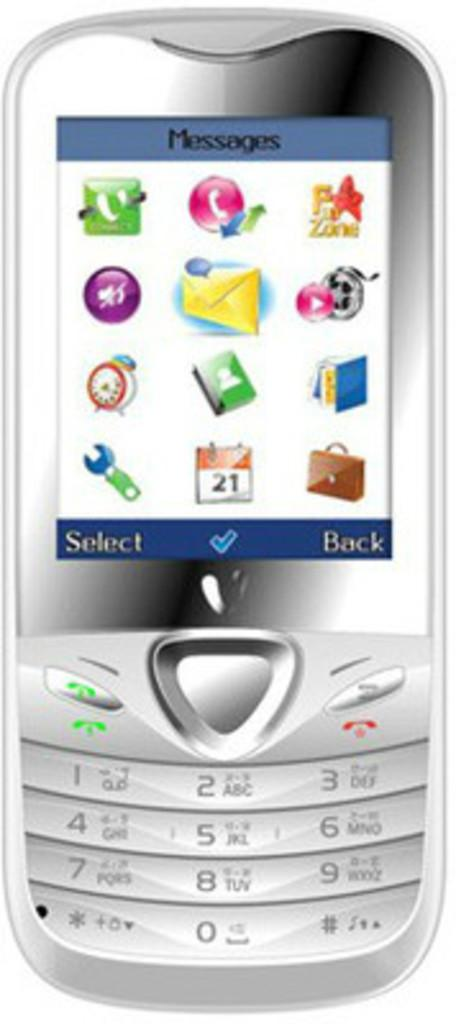<image>
Relay a brief, clear account of the picture shown. the word back is on the cell phone 